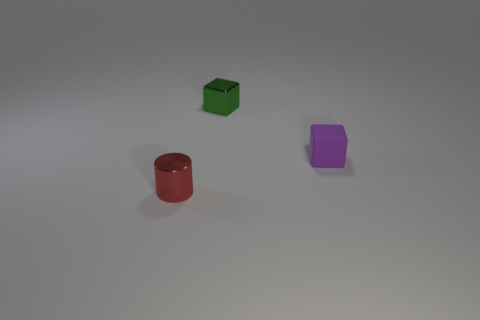Add 2 tiny objects. How many objects exist? 5 Subtract all purple blocks. How many blocks are left? 1 Subtract 1 blocks. How many blocks are left? 1 Add 3 small purple things. How many small purple things are left? 4 Add 1 blocks. How many blocks exist? 3 Subtract 0 gray cubes. How many objects are left? 3 Subtract all cylinders. How many objects are left? 2 Subtract all blue cylinders. Subtract all blue spheres. How many cylinders are left? 1 Subtract all large brown matte objects. Subtract all small blocks. How many objects are left? 1 